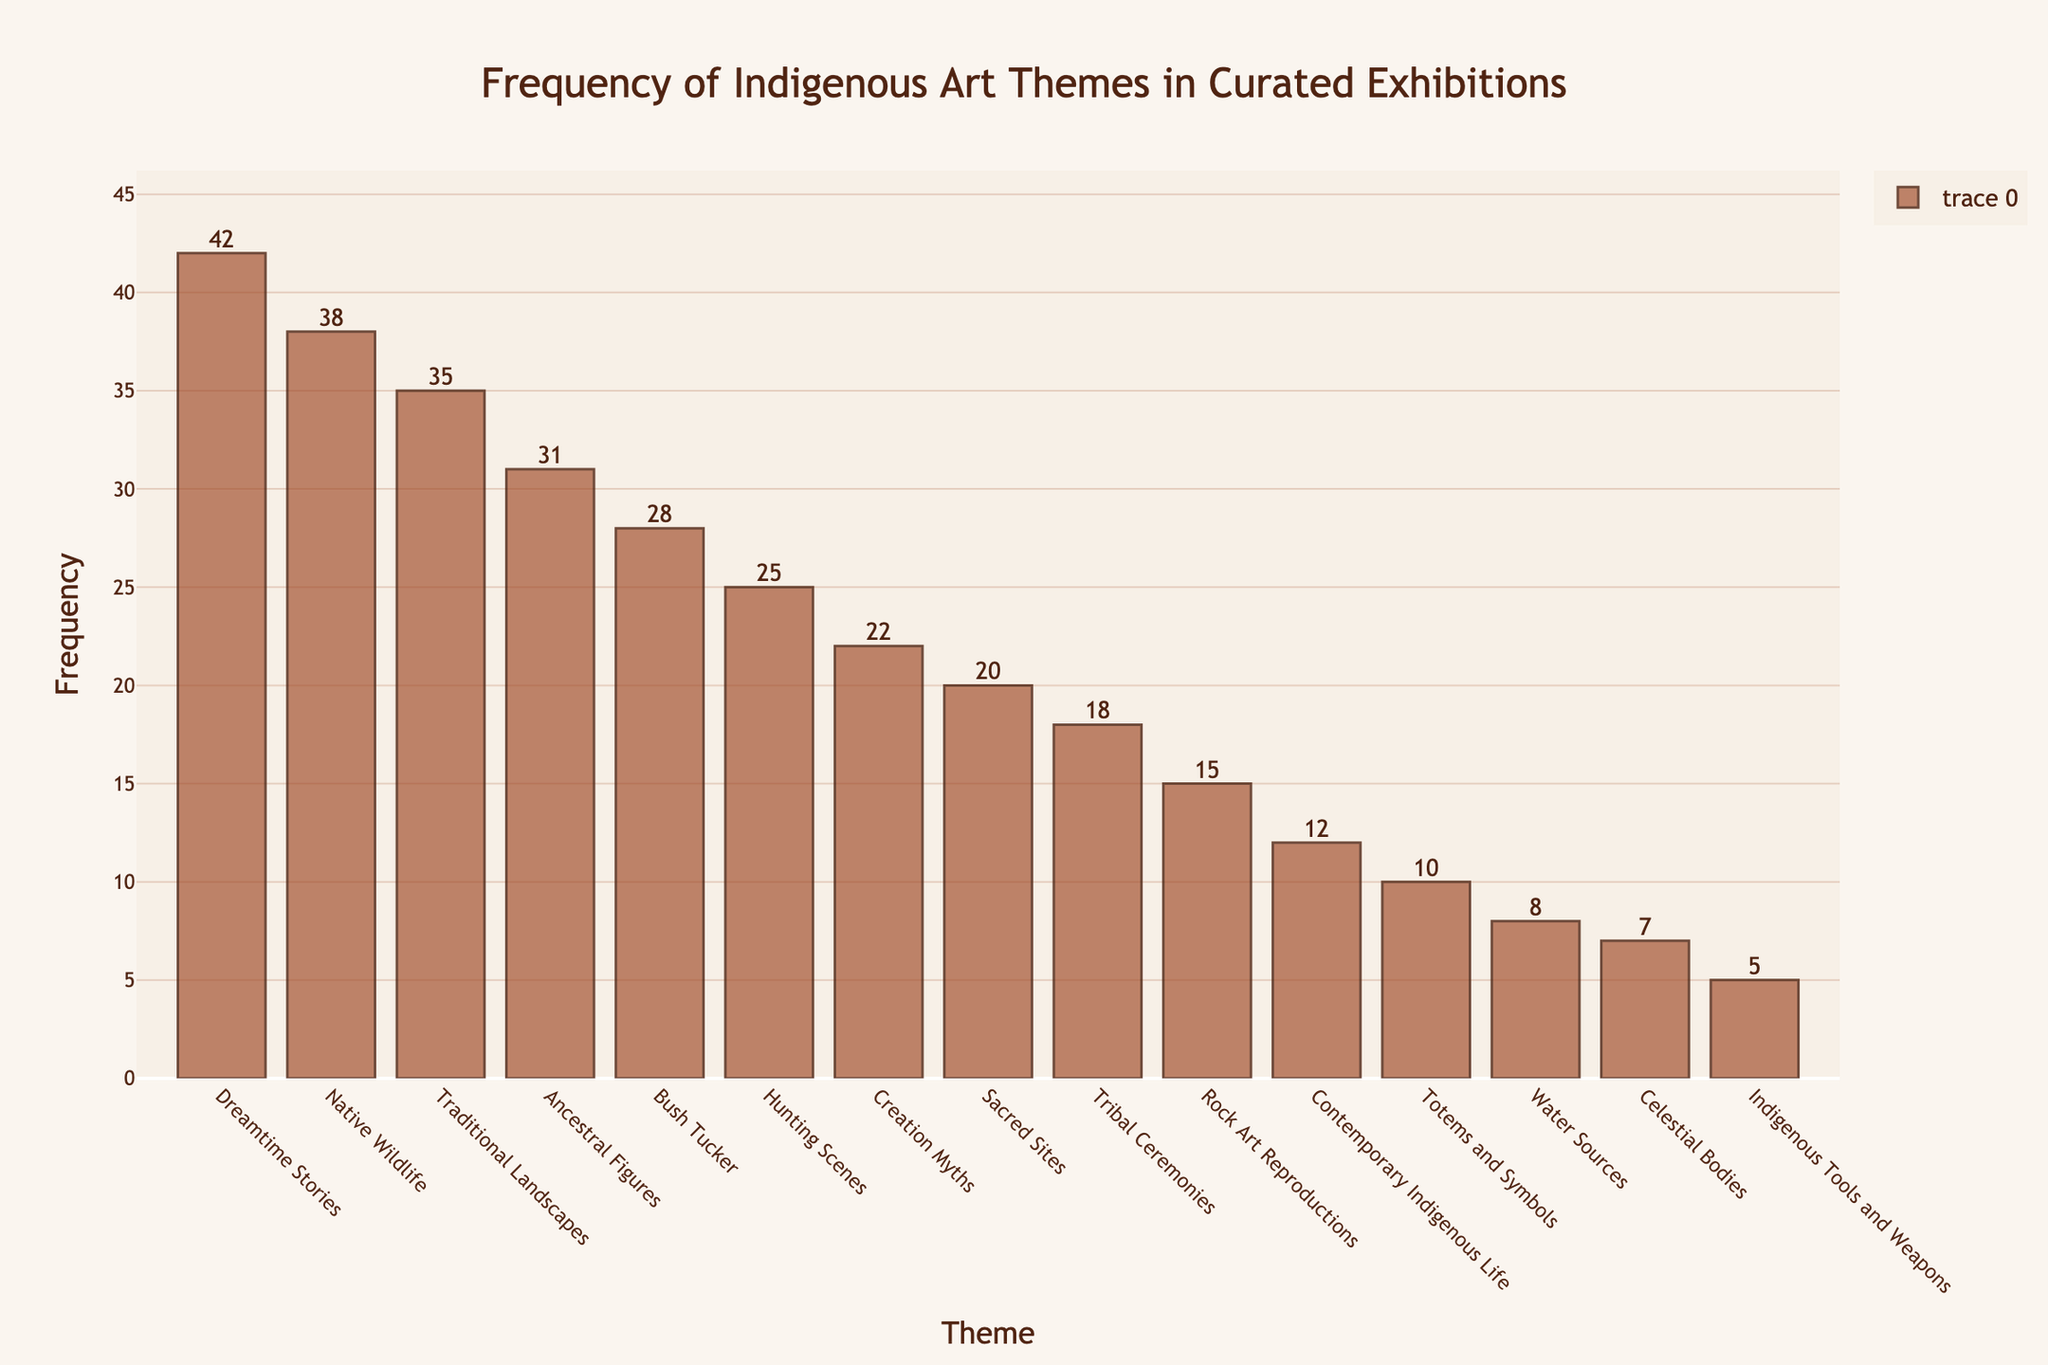What's the most frequent theme in the curated exhibitions? The figure shows various art themes along the x-axis and their corresponding frequencies along the y-axis. The tallest bar corresponds to the most frequent theme. 'Dreamtime Stories' has the highest frequency with 42.
Answer: Dreamtime Stories Which theme has the lowest frequency? To find the theme with the lowest frequency, look for the shortest bar in the chart. 'Indigenous Tools and Weapons' has the shortest bar with a frequency of 5.
Answer: Indigenous Tools and Weapons What is the combined frequency of ‘Ancestral Figures’ and ‘Bush Tucker’? Add the frequencies of 'Ancestral Figures' (31) and 'Bush Tucker' (28). 31 + 28 = 59.
Answer: 59 Which theme has a higher frequency: 'Traditional Landscapes' or 'Native Wildlife'? Compare the heights of the bars for 'Traditional Landscapes' and 'Native Wildlife'. 'Native Wildlife' has a frequency of 38, while 'Traditional Landscapes' has a frequency of 35.
Answer: Native Wildlife What is the difference in frequency between 'Hunting Scenes' and 'Contemporary Indigenous Life'? Subtract the frequency of 'Contemporary Indigenous Life' (12) from 'Hunting Scenes' (25). 25 - 12 = 13.
Answer: 13 How many themes have a frequency greater than 20? Count the number of bars exceeding the frequency value of 20. The themes are 'Dreamtime Stories', 'Native Wildlife', 'Traditional Landscapes', 'Ancestral Figures', 'Bush Tucker', 'Hunting Scenes', 'Creation Myths', and 'Sacred Sites', making a total of 8.
Answer: 8 By how much does the frequency of 'Totems and Symbols' differ from the average frequency of all themes? First, calculate the average frequency by summing all the frequencies (42 + 38 + 35 + 31 + 28 + 25 + 22 + 20 + 18 + 15 + 12 + 10 + 8 + 7 + 5 = 316) and dividing by the number of themes (15). The average frequency is 316 / 15 = 21.07. The frequency of 'Totems and Symbols' is 10. The difference is 21.07 - 10 = 11.07.
Answer: 11.07 What percentage of the total frequency does 'Rock Art Reproductions' represent? Calculate the total frequency (316). The frequency of 'Rock Art Reproductions' is 15. The percentage is (15 / 316) * 100 = 4.75%.
Answer: 4.75% Which theme has approximately the mid-range frequency value? First, identify the highest (42) and lowest (5) frequencies. The mid-range value is (42 + 5) / 2 = 23.5. The theme closest to this value is 'Creation Myths' with a frequency of 22.
Answer: Creation Myths 